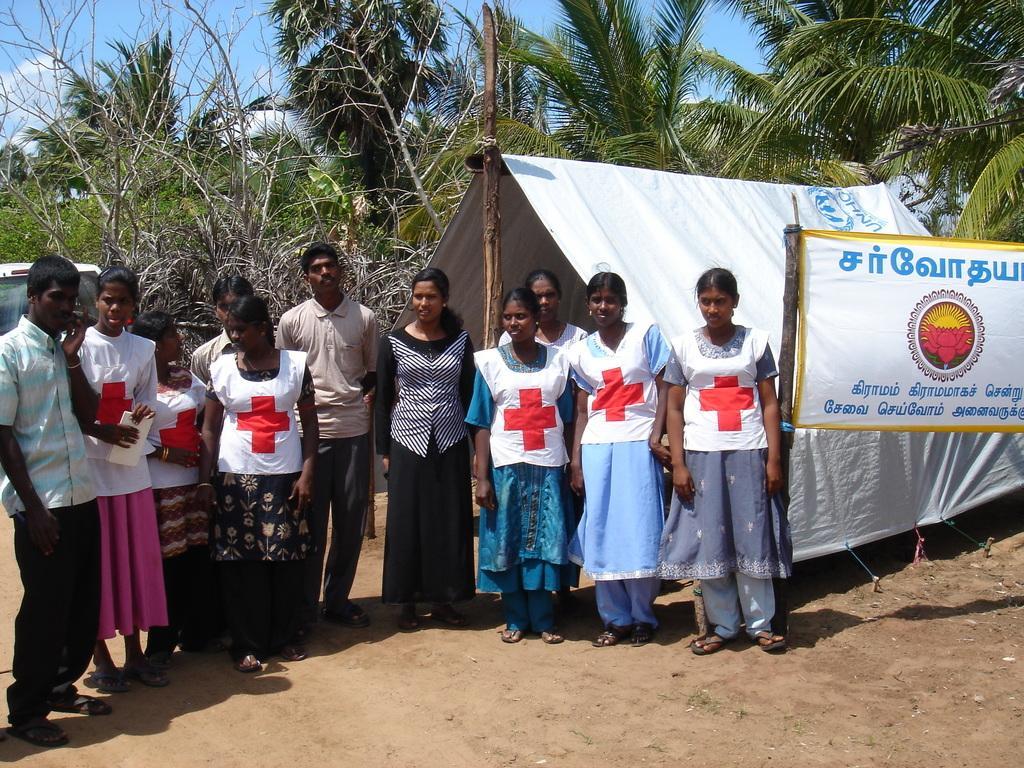In one or two sentences, can you explain what this image depicts? On the left side, there are persons in different color dresses, standing on the ground. On the right side, there is a banner attached to a wooden pole. Beside this banner, there is a white color tint. In the background, there is a vehicle, there are trees and there are clouds in the blue sky. 